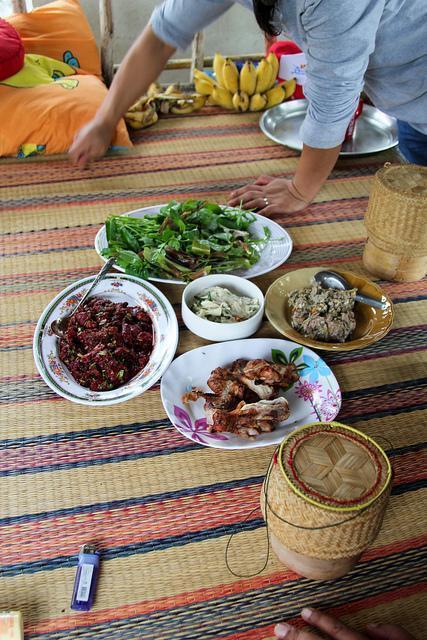What is closest to the person?
Indicate the correct response by choosing from the four available options to answer the question.
Options: Banana, barrel, baby, tiger. Banana. 